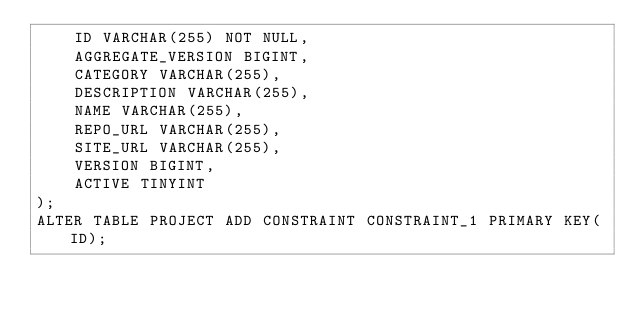Convert code to text. <code><loc_0><loc_0><loc_500><loc_500><_SQL_>    ID VARCHAR(255) NOT NULL,
    AGGREGATE_VERSION BIGINT,
    CATEGORY VARCHAR(255),
    DESCRIPTION VARCHAR(255),
    NAME VARCHAR(255),
    REPO_URL VARCHAR(255),
    SITE_URL VARCHAR(255),
    VERSION BIGINT,
    ACTIVE TINYINT
);
ALTER TABLE PROJECT ADD CONSTRAINT CONSTRAINT_1 PRIMARY KEY(ID);

</code> 